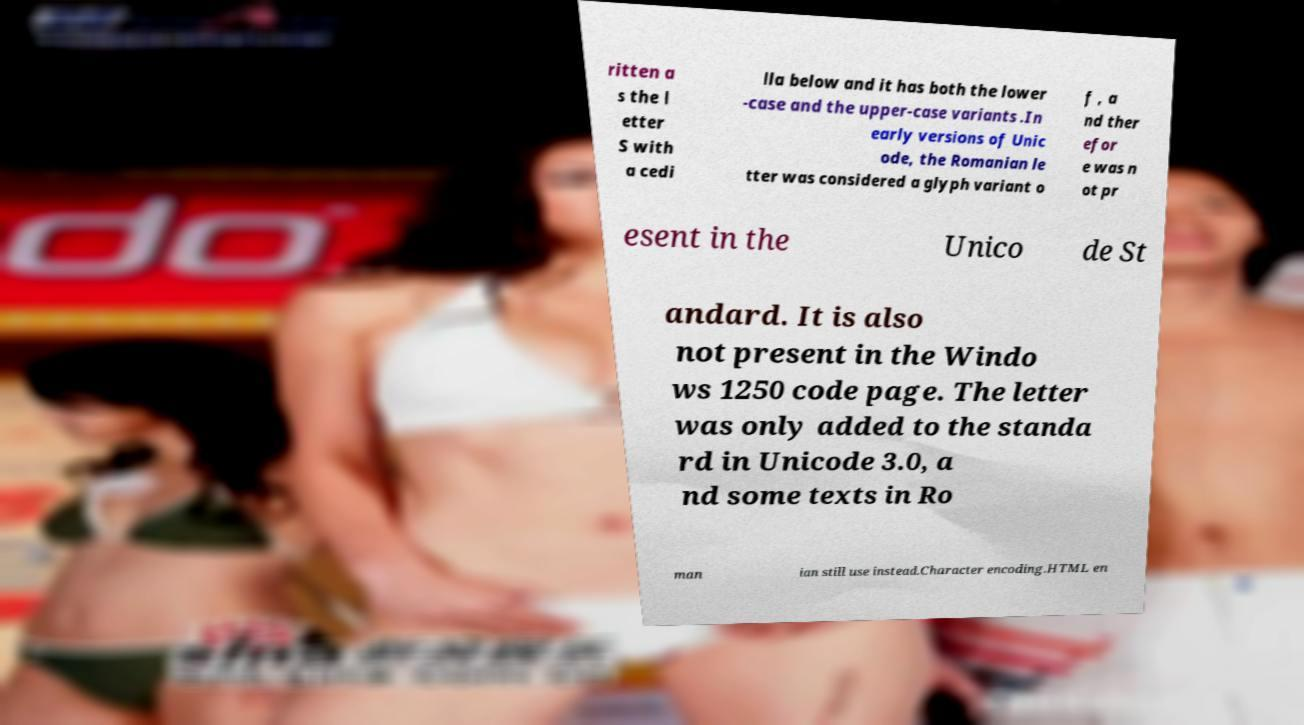For documentation purposes, I need the text within this image transcribed. Could you provide that? ritten a s the l etter S with a cedi lla below and it has both the lower -case and the upper-case variants .In early versions of Unic ode, the Romanian le tter was considered a glyph variant o f , a nd ther efor e was n ot pr esent in the Unico de St andard. It is also not present in the Windo ws 1250 code page. The letter was only added to the standa rd in Unicode 3.0, a nd some texts in Ro man ian still use instead.Character encoding.HTML en 